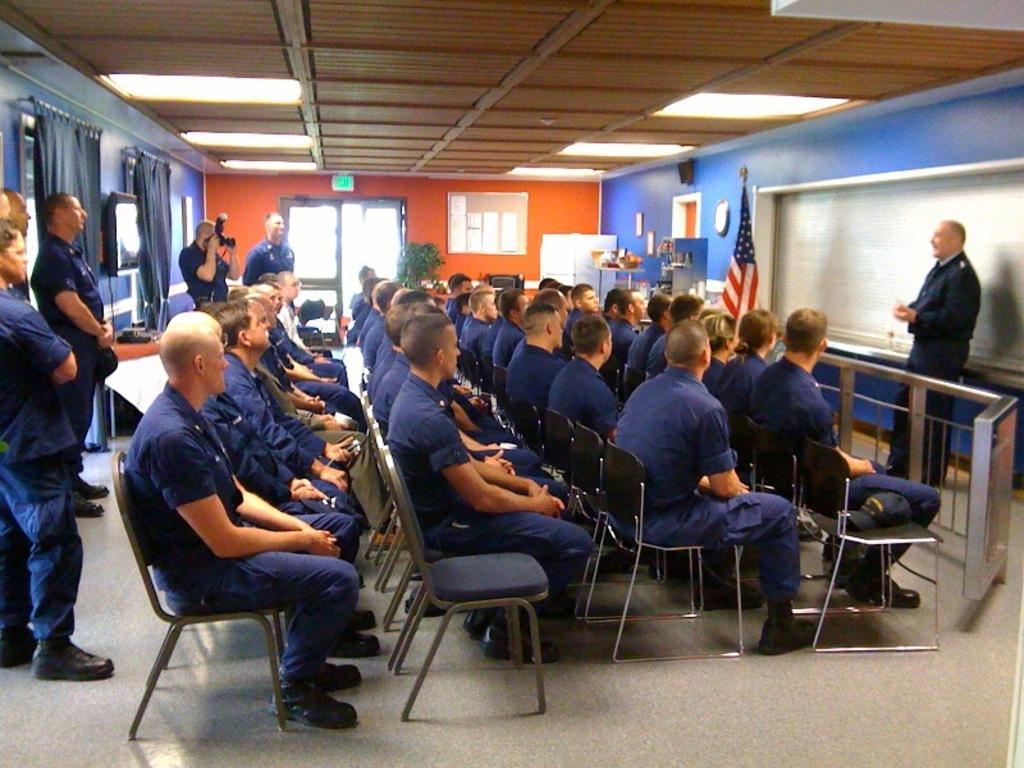In one or two sentences, can you explain what this image depicts? Here we can see some persons are sitting on the chairs. This is floor. Here we can see a flag and this is board. There is a door and this is wall. Here we can see curtains and this is screen. There are lights and this is roof. Here we can see some persons are standing on the floor. 